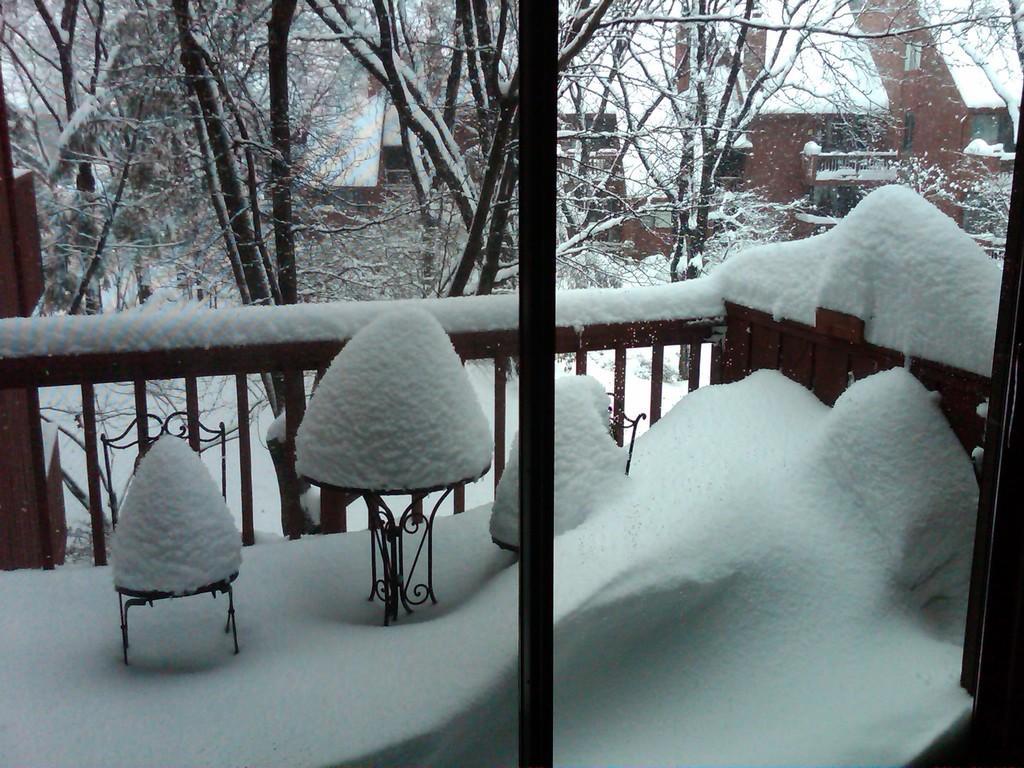Could you give a brief overview of what you see in this image? In this image, there is a window and through the window, we can see trees, buildings, railings, poles and stands are covered with snow. 